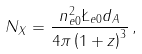<formula> <loc_0><loc_0><loc_500><loc_500>N _ { X } = \frac { n _ { e 0 } ^ { 2 } \L _ { e 0 } d _ { A } } { 4 \pi \left ( 1 + z \right ) ^ { 3 } } \, ,</formula> 